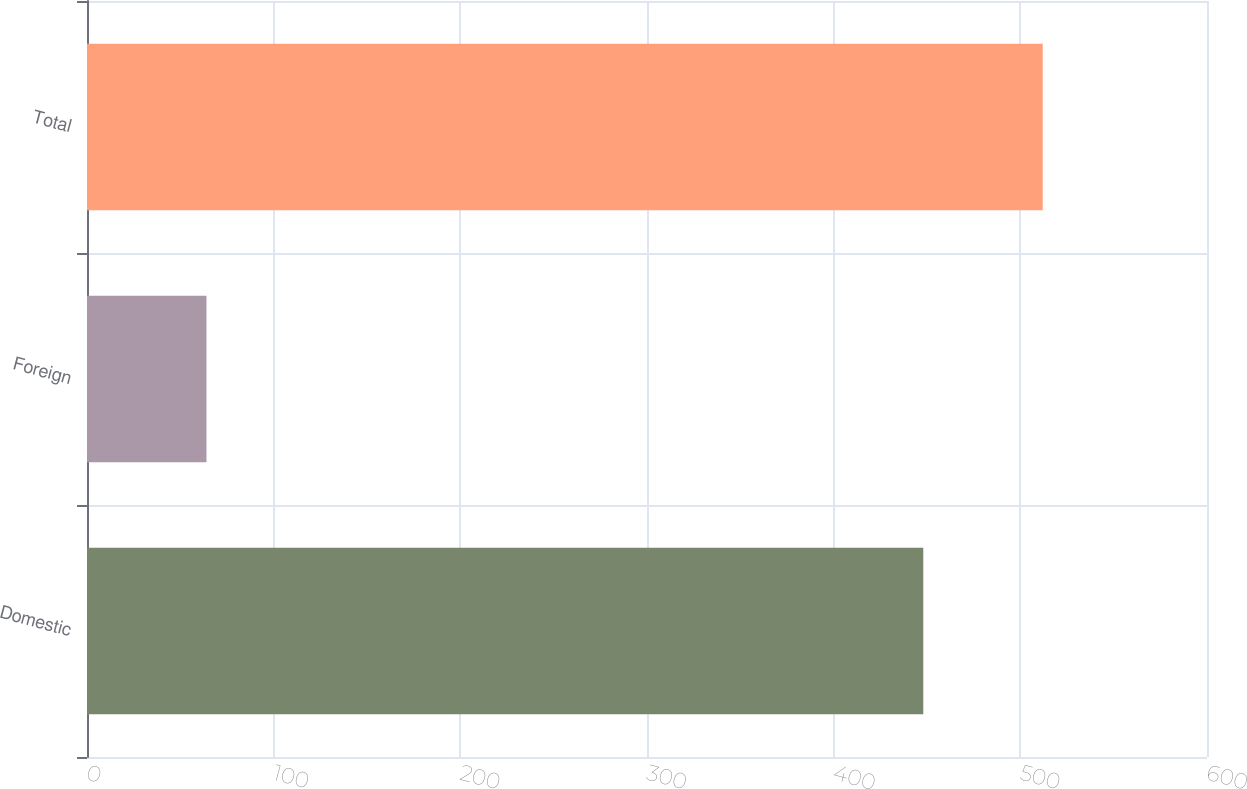Convert chart to OTSL. <chart><loc_0><loc_0><loc_500><loc_500><bar_chart><fcel>Domestic<fcel>Foreign<fcel>Total<nl><fcel>448<fcel>64<fcel>512<nl></chart> 